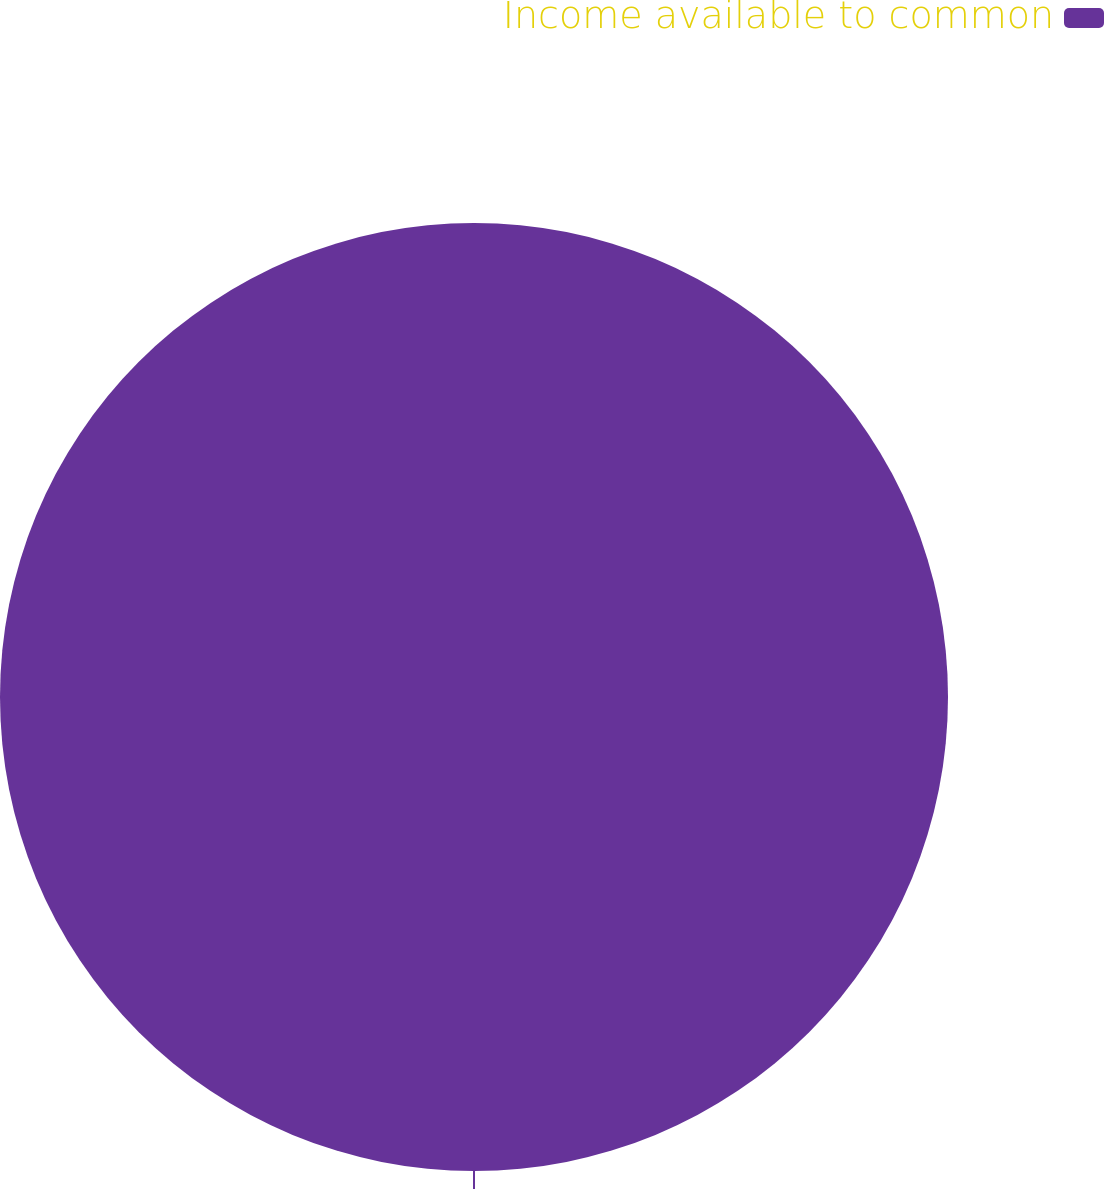Convert chart to OTSL. <chart><loc_0><loc_0><loc_500><loc_500><pie_chart><fcel>Income available to common<nl><fcel>100.0%<nl></chart> 